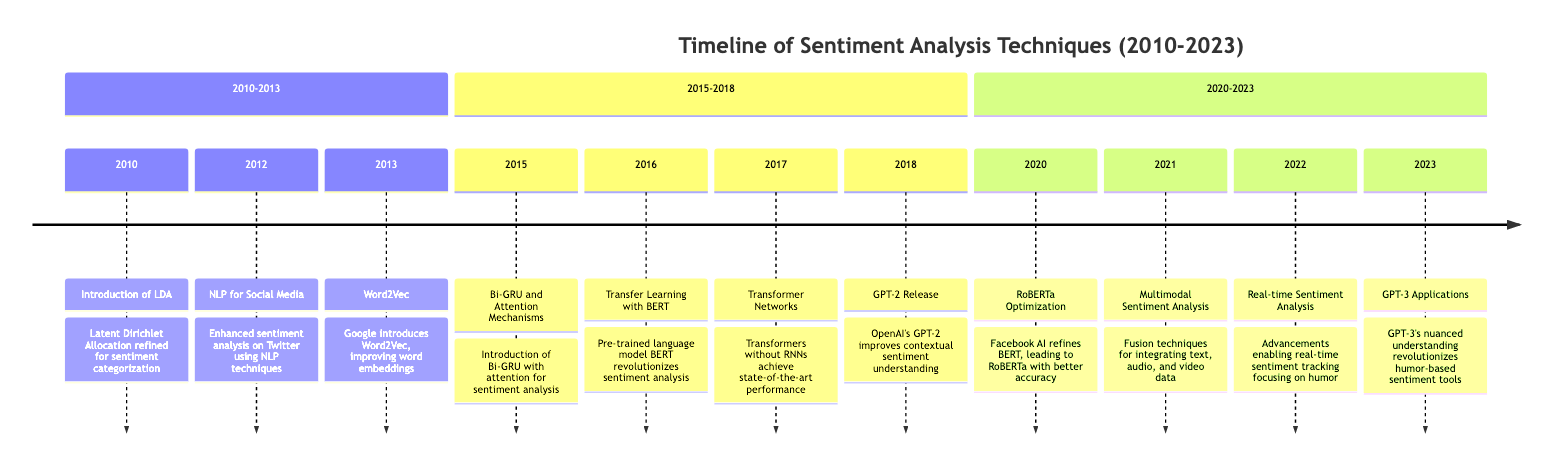What is the key technique introduced in 2010 for sentiment analysis? The diagram mentions that the key technique introduced in 2010 is "Latent Dirichlet Allocation refined for sentiment categorization."
Answer: Latent Dirichlet Allocation Which year marked the introduction of BERT for sentiment analysis? According to the diagram, BERT was introduced in 2016 as a key milestone in sentiment analysis techniques.
Answer: 2016 How many key milestones were noted between 2010 and 2023? By counting the milestones listed in the timeline segments, there are 10 key milestones noted from 2010 to 2023.
Answer: 10 What major algorithm improvement occurred in 2021? The diagram indicates that "Multimodal Sentiment Analysis" involving fusion techniques was a major improvement in 2021.
Answer: Multimodal Sentiment Analysis Which NLP technique was enhanced for sentiment analysis on Twitter in 2012? The diagram specifies that NLP techniques were enhanced for sentiment analysis on Twitter during that year.
Answer: NLP for Social Media What significant release occurred in 2018 that impacted sentiment analysis? According to the diagram, the release of "GPT-2" in 2018 greatly improved contextual sentiment understanding.
Answer: GPT-2 In what year did RoBERTa show better accuracy in sentiment analysis? The diagram shows that RoBERTa was optimized and released in 2020, leading to better accuracy.
Answer: 2020 Which technique was mentioned as enabling real-time sentiment tracking in 2022? As per the timeline, advancements allowing real-time sentiment analysis became significant in 2022.
Answer: Real-time Sentiment Analysis What milestone specifically focused on humor in 2022? The timeline indicates that advancements in "real-time sentiment tracking focusing on humor" occurred in 2022.
Answer: real-time sentiment tracking focusing on humor 